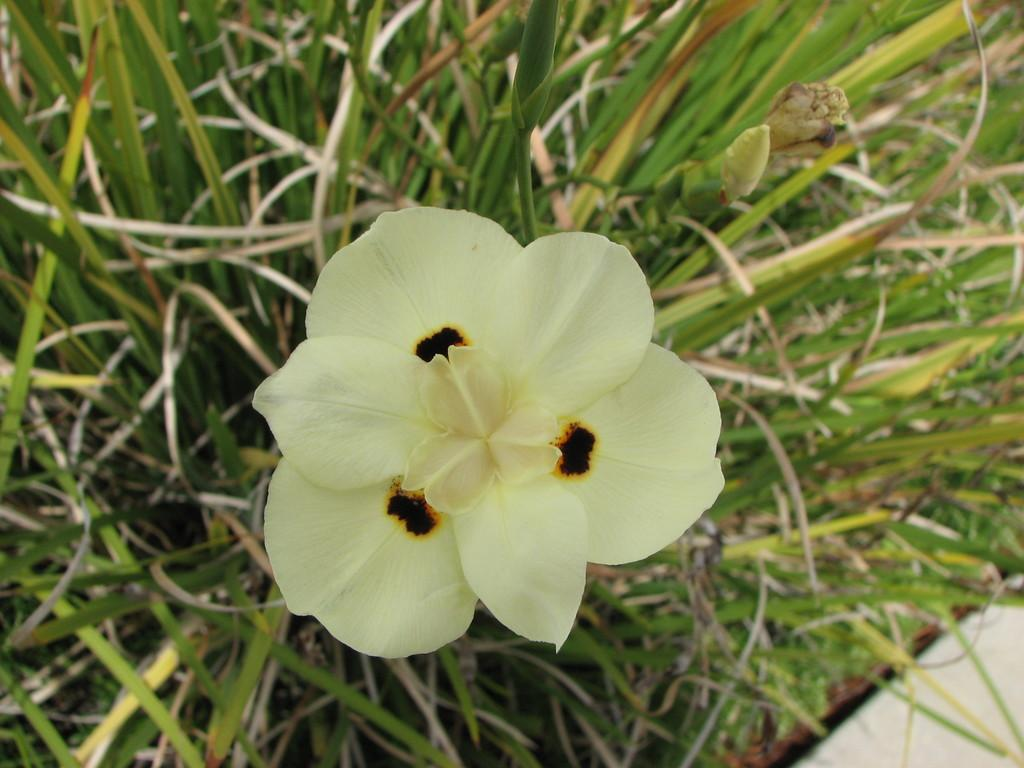What type of vegetation can be seen in the image? There is grass in the image. What other living organism is present in the image? There is a flower in the image. What is the color of the flower? The flower is yellow. Are there any additional details about the flower's appearance? Yes, the flower has black color marks on it. How much debt does the sister owe in the image? There is no mention of a sister or any debt in the image. 